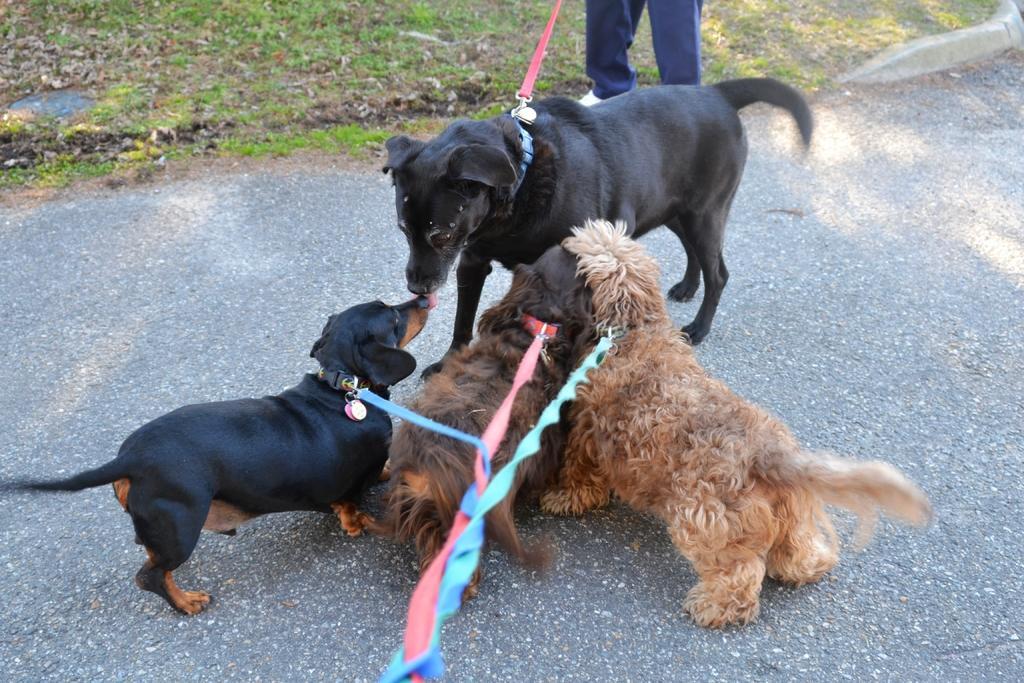Could you give a brief overview of what you see in this image? In this image we can see four dogs. Two are in black color, one is in dark brown color and the other one is in light brown color. Behind one person is standing and grassy land is present. 